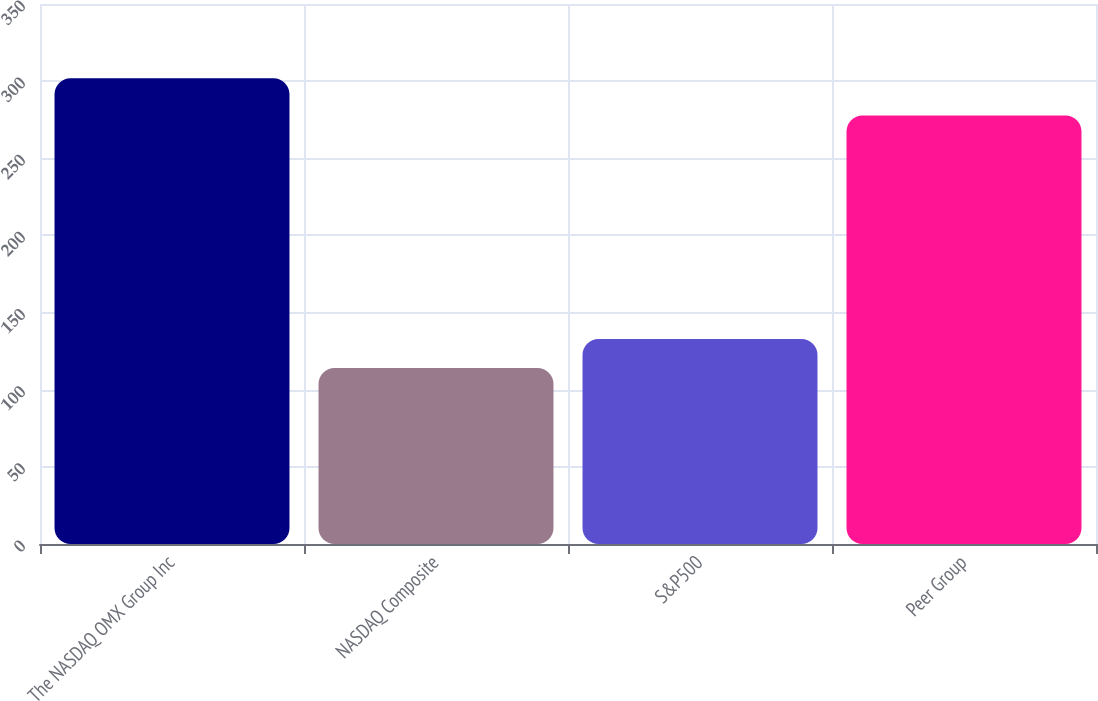<chart> <loc_0><loc_0><loc_500><loc_500><bar_chart><fcel>The NASDAQ OMX Group Inc<fcel>NASDAQ Composite<fcel>S&P500<fcel>Peer Group<nl><fcel>301.86<fcel>114.01<fcel>132.8<fcel>277.66<nl></chart> 